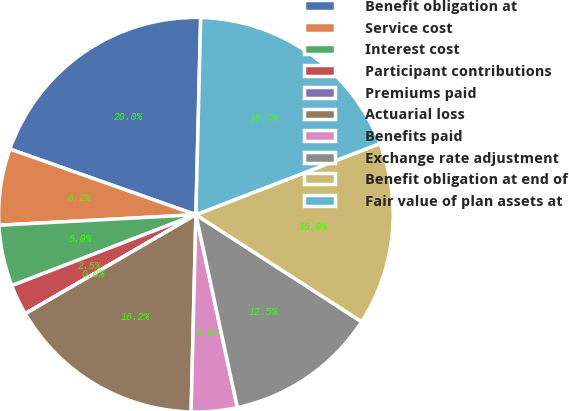Convert chart. <chart><loc_0><loc_0><loc_500><loc_500><pie_chart><fcel>Benefit obligation at<fcel>Service cost<fcel>Interest cost<fcel>Participant contributions<fcel>Premiums paid<fcel>Actuarial loss<fcel>Benefits paid<fcel>Exchange rate adjustment<fcel>Benefit obligation at end of<fcel>Fair value of plan assets at<nl><fcel>19.99%<fcel>6.25%<fcel>5.0%<fcel>2.51%<fcel>0.01%<fcel>16.24%<fcel>3.76%<fcel>12.5%<fcel>15.0%<fcel>18.74%<nl></chart> 